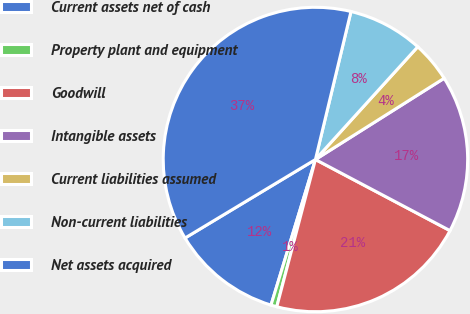Convert chart. <chart><loc_0><loc_0><loc_500><loc_500><pie_chart><fcel>Current assets net of cash<fcel>Property plant and equipment<fcel>Goodwill<fcel>Intangible assets<fcel>Current liabilities assumed<fcel>Non-current liabilities<fcel>Net assets acquired<nl><fcel>11.66%<fcel>0.63%<fcel>21.35%<fcel>16.7%<fcel>4.31%<fcel>7.98%<fcel>37.38%<nl></chart> 